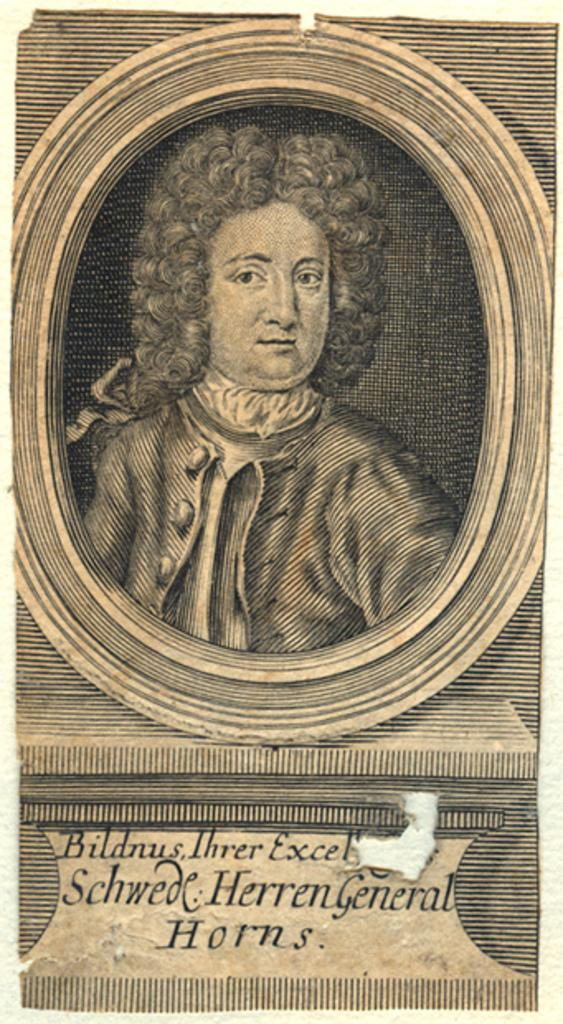Provide a one-sentence caption for the provided image. An antique picture of Ihrer Bildnus, Schwede Herren General Horns can be seen. 